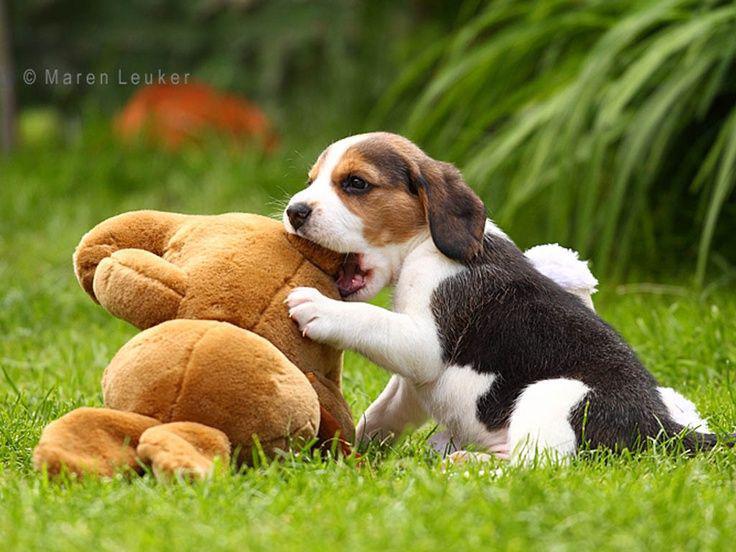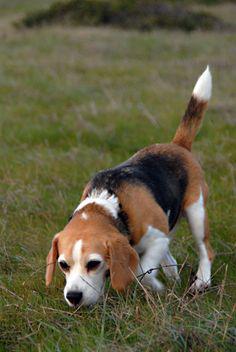The first image is the image on the left, the second image is the image on the right. Considering the images on both sides, is "In one image, two people wearing white pants and dark tops, and carrying dog handling equipment are standing with a pack of dogs." valid? Answer yes or no. No. The first image is the image on the left, the second image is the image on the right. For the images shown, is this caption "An image shows two people wearing white trousers standing by a pack of hound dogs." true? Answer yes or no. No. 